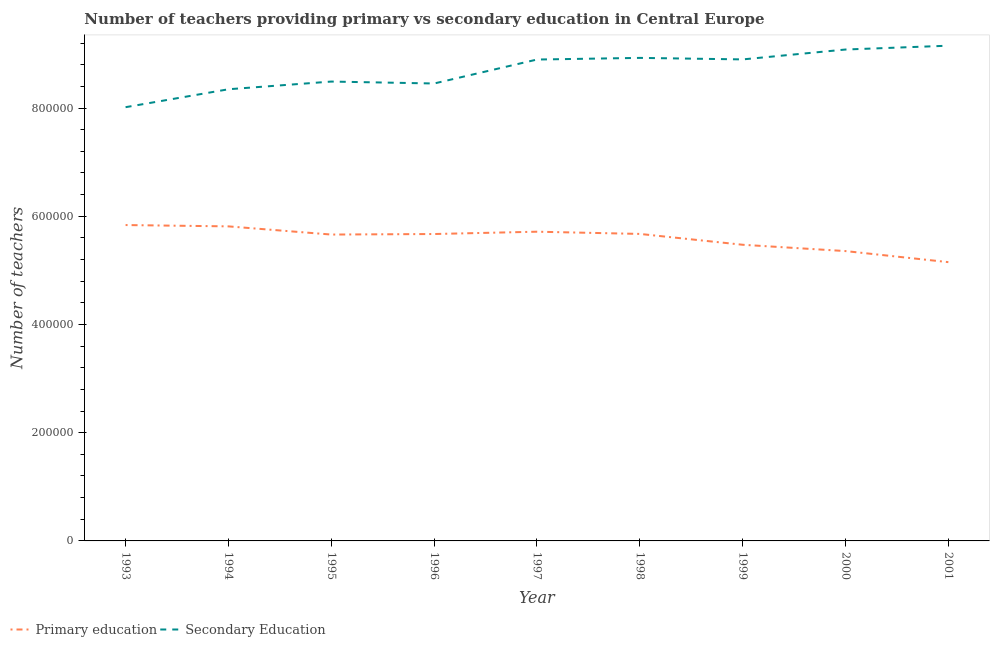How many different coloured lines are there?
Provide a short and direct response. 2. Does the line corresponding to number of secondary teachers intersect with the line corresponding to number of primary teachers?
Offer a very short reply. No. Is the number of lines equal to the number of legend labels?
Make the answer very short. Yes. What is the number of primary teachers in 1994?
Offer a very short reply. 5.81e+05. Across all years, what is the maximum number of secondary teachers?
Provide a succinct answer. 9.15e+05. Across all years, what is the minimum number of secondary teachers?
Your answer should be very brief. 8.02e+05. In which year was the number of primary teachers maximum?
Offer a terse response. 1993. In which year was the number of secondary teachers minimum?
Give a very brief answer. 1993. What is the total number of secondary teachers in the graph?
Ensure brevity in your answer.  7.83e+06. What is the difference between the number of primary teachers in 1995 and that in 1999?
Make the answer very short. 1.89e+04. What is the difference between the number of secondary teachers in 1994 and the number of primary teachers in 1993?
Ensure brevity in your answer.  2.51e+05. What is the average number of secondary teachers per year?
Keep it short and to the point. 8.70e+05. In the year 1999, what is the difference between the number of secondary teachers and number of primary teachers?
Offer a terse response. 3.43e+05. What is the ratio of the number of primary teachers in 1995 to that in 1998?
Your answer should be compact. 1. Is the number of primary teachers in 1997 less than that in 1998?
Your answer should be compact. No. Is the difference between the number of primary teachers in 1993 and 1999 greater than the difference between the number of secondary teachers in 1993 and 1999?
Your response must be concise. Yes. What is the difference between the highest and the second highest number of primary teachers?
Your response must be concise. 2451.12. What is the difference between the highest and the lowest number of primary teachers?
Keep it short and to the point. 6.86e+04. Does the number of primary teachers monotonically increase over the years?
Your answer should be compact. No. How many lines are there?
Your response must be concise. 2. How many years are there in the graph?
Your answer should be compact. 9. Where does the legend appear in the graph?
Your response must be concise. Bottom left. How many legend labels are there?
Keep it short and to the point. 2. What is the title of the graph?
Keep it short and to the point. Number of teachers providing primary vs secondary education in Central Europe. Does "Agricultural land" appear as one of the legend labels in the graph?
Provide a short and direct response. No. What is the label or title of the X-axis?
Ensure brevity in your answer.  Year. What is the label or title of the Y-axis?
Offer a terse response. Number of teachers. What is the Number of teachers of Primary education in 1993?
Make the answer very short. 5.84e+05. What is the Number of teachers in Secondary Education in 1993?
Keep it short and to the point. 8.02e+05. What is the Number of teachers of Primary education in 1994?
Your response must be concise. 5.81e+05. What is the Number of teachers of Secondary Education in 1994?
Provide a succinct answer. 8.35e+05. What is the Number of teachers in Primary education in 1995?
Keep it short and to the point. 5.66e+05. What is the Number of teachers in Secondary Education in 1995?
Your response must be concise. 8.49e+05. What is the Number of teachers in Primary education in 1996?
Your answer should be compact. 5.67e+05. What is the Number of teachers in Secondary Education in 1996?
Provide a short and direct response. 8.45e+05. What is the Number of teachers of Primary education in 1997?
Your answer should be compact. 5.71e+05. What is the Number of teachers of Secondary Education in 1997?
Your response must be concise. 8.90e+05. What is the Number of teachers in Primary education in 1998?
Your answer should be very brief. 5.67e+05. What is the Number of teachers of Secondary Education in 1998?
Provide a succinct answer. 8.93e+05. What is the Number of teachers in Primary education in 1999?
Offer a terse response. 5.47e+05. What is the Number of teachers in Secondary Education in 1999?
Offer a terse response. 8.90e+05. What is the Number of teachers in Primary education in 2000?
Provide a short and direct response. 5.36e+05. What is the Number of teachers of Secondary Education in 2000?
Offer a very short reply. 9.08e+05. What is the Number of teachers of Primary education in 2001?
Your answer should be very brief. 5.15e+05. What is the Number of teachers of Secondary Education in 2001?
Your answer should be compact. 9.15e+05. Across all years, what is the maximum Number of teachers in Primary education?
Your response must be concise. 5.84e+05. Across all years, what is the maximum Number of teachers in Secondary Education?
Ensure brevity in your answer.  9.15e+05. Across all years, what is the minimum Number of teachers in Primary education?
Your answer should be very brief. 5.15e+05. Across all years, what is the minimum Number of teachers of Secondary Education?
Offer a terse response. 8.02e+05. What is the total Number of teachers in Primary education in the graph?
Your answer should be compact. 5.04e+06. What is the total Number of teachers in Secondary Education in the graph?
Make the answer very short. 7.83e+06. What is the difference between the Number of teachers in Primary education in 1993 and that in 1994?
Your answer should be compact. 2451.12. What is the difference between the Number of teachers of Secondary Education in 1993 and that in 1994?
Offer a terse response. -3.31e+04. What is the difference between the Number of teachers in Primary education in 1993 and that in 1995?
Your answer should be very brief. 1.76e+04. What is the difference between the Number of teachers in Secondary Education in 1993 and that in 1995?
Keep it short and to the point. -4.74e+04. What is the difference between the Number of teachers in Primary education in 1993 and that in 1996?
Keep it short and to the point. 1.66e+04. What is the difference between the Number of teachers in Secondary Education in 1993 and that in 1996?
Offer a very short reply. -4.38e+04. What is the difference between the Number of teachers in Primary education in 1993 and that in 1997?
Make the answer very short. 1.23e+04. What is the difference between the Number of teachers in Secondary Education in 1993 and that in 1997?
Offer a very short reply. -8.81e+04. What is the difference between the Number of teachers in Primary education in 1993 and that in 1998?
Make the answer very short. 1.64e+04. What is the difference between the Number of teachers in Secondary Education in 1993 and that in 1998?
Your answer should be very brief. -9.11e+04. What is the difference between the Number of teachers of Primary education in 1993 and that in 1999?
Keep it short and to the point. 3.64e+04. What is the difference between the Number of teachers of Secondary Education in 1993 and that in 1999?
Make the answer very short. -8.83e+04. What is the difference between the Number of teachers in Primary education in 1993 and that in 2000?
Your answer should be very brief. 4.81e+04. What is the difference between the Number of teachers of Secondary Education in 1993 and that in 2000?
Make the answer very short. -1.07e+05. What is the difference between the Number of teachers in Primary education in 1993 and that in 2001?
Provide a succinct answer. 6.86e+04. What is the difference between the Number of teachers in Secondary Education in 1993 and that in 2001?
Give a very brief answer. -1.14e+05. What is the difference between the Number of teachers in Primary education in 1994 and that in 1995?
Provide a succinct answer. 1.51e+04. What is the difference between the Number of teachers in Secondary Education in 1994 and that in 1995?
Keep it short and to the point. -1.42e+04. What is the difference between the Number of teachers of Primary education in 1994 and that in 1996?
Your answer should be very brief. 1.41e+04. What is the difference between the Number of teachers of Secondary Education in 1994 and that in 1996?
Provide a short and direct response. -1.07e+04. What is the difference between the Number of teachers of Primary education in 1994 and that in 1997?
Your answer should be compact. 9834.69. What is the difference between the Number of teachers in Secondary Education in 1994 and that in 1997?
Offer a terse response. -5.49e+04. What is the difference between the Number of teachers of Primary education in 1994 and that in 1998?
Ensure brevity in your answer.  1.39e+04. What is the difference between the Number of teachers in Secondary Education in 1994 and that in 1998?
Your answer should be very brief. -5.80e+04. What is the difference between the Number of teachers of Primary education in 1994 and that in 1999?
Your answer should be very brief. 3.40e+04. What is the difference between the Number of teachers in Secondary Education in 1994 and that in 1999?
Provide a short and direct response. -5.52e+04. What is the difference between the Number of teachers of Primary education in 1994 and that in 2000?
Provide a succinct answer. 4.57e+04. What is the difference between the Number of teachers in Secondary Education in 1994 and that in 2000?
Your answer should be compact. -7.34e+04. What is the difference between the Number of teachers in Primary education in 1994 and that in 2001?
Provide a succinct answer. 6.61e+04. What is the difference between the Number of teachers in Secondary Education in 1994 and that in 2001?
Keep it short and to the point. -8.05e+04. What is the difference between the Number of teachers of Primary education in 1995 and that in 1996?
Your answer should be very brief. -986.69. What is the difference between the Number of teachers in Secondary Education in 1995 and that in 1996?
Your answer should be very brief. 3568.75. What is the difference between the Number of teachers in Primary education in 1995 and that in 1997?
Your response must be concise. -5271.88. What is the difference between the Number of teachers of Secondary Education in 1995 and that in 1997?
Ensure brevity in your answer.  -4.07e+04. What is the difference between the Number of teachers in Primary education in 1995 and that in 1998?
Your answer should be compact. -1163.19. What is the difference between the Number of teachers in Secondary Education in 1995 and that in 1998?
Your answer should be compact. -4.38e+04. What is the difference between the Number of teachers of Primary education in 1995 and that in 1999?
Make the answer very short. 1.89e+04. What is the difference between the Number of teachers of Secondary Education in 1995 and that in 1999?
Your answer should be compact. -4.09e+04. What is the difference between the Number of teachers of Primary education in 1995 and that in 2000?
Give a very brief answer. 3.05e+04. What is the difference between the Number of teachers in Secondary Education in 1995 and that in 2000?
Offer a very short reply. -5.92e+04. What is the difference between the Number of teachers of Primary education in 1995 and that in 2001?
Offer a very short reply. 5.10e+04. What is the difference between the Number of teachers of Secondary Education in 1995 and that in 2001?
Your response must be concise. -6.63e+04. What is the difference between the Number of teachers of Primary education in 1996 and that in 1997?
Your answer should be very brief. -4285.19. What is the difference between the Number of teachers in Secondary Education in 1996 and that in 1997?
Provide a short and direct response. -4.43e+04. What is the difference between the Number of teachers in Primary education in 1996 and that in 1998?
Your answer should be compact. -176.5. What is the difference between the Number of teachers in Secondary Education in 1996 and that in 1998?
Provide a short and direct response. -4.73e+04. What is the difference between the Number of teachers of Primary education in 1996 and that in 1999?
Give a very brief answer. 1.99e+04. What is the difference between the Number of teachers of Secondary Education in 1996 and that in 1999?
Ensure brevity in your answer.  -4.45e+04. What is the difference between the Number of teachers of Primary education in 1996 and that in 2000?
Your answer should be compact. 3.15e+04. What is the difference between the Number of teachers of Secondary Education in 1996 and that in 2000?
Offer a terse response. -6.28e+04. What is the difference between the Number of teachers of Primary education in 1996 and that in 2001?
Your response must be concise. 5.20e+04. What is the difference between the Number of teachers of Secondary Education in 1996 and that in 2001?
Keep it short and to the point. -6.98e+04. What is the difference between the Number of teachers in Primary education in 1997 and that in 1998?
Give a very brief answer. 4108.69. What is the difference between the Number of teachers in Secondary Education in 1997 and that in 1998?
Provide a short and direct response. -3056.06. What is the difference between the Number of teachers of Primary education in 1997 and that in 1999?
Your answer should be very brief. 2.41e+04. What is the difference between the Number of teachers in Secondary Education in 1997 and that in 1999?
Your answer should be very brief. -243.56. What is the difference between the Number of teachers in Primary education in 1997 and that in 2000?
Give a very brief answer. 3.58e+04. What is the difference between the Number of teachers of Secondary Education in 1997 and that in 2000?
Keep it short and to the point. -1.85e+04. What is the difference between the Number of teachers in Primary education in 1997 and that in 2001?
Give a very brief answer. 5.63e+04. What is the difference between the Number of teachers in Secondary Education in 1997 and that in 2001?
Your response must be concise. -2.56e+04. What is the difference between the Number of teachers of Primary education in 1998 and that in 1999?
Your answer should be compact. 2.00e+04. What is the difference between the Number of teachers of Secondary Education in 1998 and that in 1999?
Keep it short and to the point. 2812.5. What is the difference between the Number of teachers in Primary education in 1998 and that in 2000?
Your response must be concise. 3.17e+04. What is the difference between the Number of teachers of Secondary Education in 1998 and that in 2000?
Provide a short and direct response. -1.55e+04. What is the difference between the Number of teachers in Primary education in 1998 and that in 2001?
Keep it short and to the point. 5.22e+04. What is the difference between the Number of teachers in Secondary Education in 1998 and that in 2001?
Give a very brief answer. -2.25e+04. What is the difference between the Number of teachers of Primary education in 1999 and that in 2000?
Offer a terse response. 1.17e+04. What is the difference between the Number of teachers in Secondary Education in 1999 and that in 2000?
Give a very brief answer. -1.83e+04. What is the difference between the Number of teachers in Primary education in 1999 and that in 2001?
Your answer should be compact. 3.21e+04. What is the difference between the Number of teachers of Secondary Education in 1999 and that in 2001?
Provide a succinct answer. -2.53e+04. What is the difference between the Number of teachers in Primary education in 2000 and that in 2001?
Provide a short and direct response. 2.04e+04. What is the difference between the Number of teachers in Secondary Education in 2000 and that in 2001?
Provide a short and direct response. -7063.25. What is the difference between the Number of teachers of Primary education in 1993 and the Number of teachers of Secondary Education in 1994?
Provide a succinct answer. -2.51e+05. What is the difference between the Number of teachers of Primary education in 1993 and the Number of teachers of Secondary Education in 1995?
Offer a very short reply. -2.65e+05. What is the difference between the Number of teachers in Primary education in 1993 and the Number of teachers in Secondary Education in 1996?
Your response must be concise. -2.62e+05. What is the difference between the Number of teachers of Primary education in 1993 and the Number of teachers of Secondary Education in 1997?
Make the answer very short. -3.06e+05. What is the difference between the Number of teachers in Primary education in 1993 and the Number of teachers in Secondary Education in 1998?
Your response must be concise. -3.09e+05. What is the difference between the Number of teachers of Primary education in 1993 and the Number of teachers of Secondary Education in 1999?
Keep it short and to the point. -3.06e+05. What is the difference between the Number of teachers in Primary education in 1993 and the Number of teachers in Secondary Education in 2000?
Offer a terse response. -3.24e+05. What is the difference between the Number of teachers in Primary education in 1993 and the Number of teachers in Secondary Education in 2001?
Keep it short and to the point. -3.31e+05. What is the difference between the Number of teachers in Primary education in 1994 and the Number of teachers in Secondary Education in 1995?
Your response must be concise. -2.68e+05. What is the difference between the Number of teachers in Primary education in 1994 and the Number of teachers in Secondary Education in 1996?
Provide a succinct answer. -2.64e+05. What is the difference between the Number of teachers in Primary education in 1994 and the Number of teachers in Secondary Education in 1997?
Your answer should be very brief. -3.08e+05. What is the difference between the Number of teachers of Primary education in 1994 and the Number of teachers of Secondary Education in 1998?
Your response must be concise. -3.11e+05. What is the difference between the Number of teachers in Primary education in 1994 and the Number of teachers in Secondary Education in 1999?
Make the answer very short. -3.09e+05. What is the difference between the Number of teachers of Primary education in 1994 and the Number of teachers of Secondary Education in 2000?
Offer a terse response. -3.27e+05. What is the difference between the Number of teachers in Primary education in 1994 and the Number of teachers in Secondary Education in 2001?
Ensure brevity in your answer.  -3.34e+05. What is the difference between the Number of teachers of Primary education in 1995 and the Number of teachers of Secondary Education in 1996?
Provide a short and direct response. -2.79e+05. What is the difference between the Number of teachers of Primary education in 1995 and the Number of teachers of Secondary Education in 1997?
Give a very brief answer. -3.23e+05. What is the difference between the Number of teachers of Primary education in 1995 and the Number of teachers of Secondary Education in 1998?
Your answer should be very brief. -3.27e+05. What is the difference between the Number of teachers in Primary education in 1995 and the Number of teachers in Secondary Education in 1999?
Offer a very short reply. -3.24e+05. What is the difference between the Number of teachers of Primary education in 1995 and the Number of teachers of Secondary Education in 2000?
Give a very brief answer. -3.42e+05. What is the difference between the Number of teachers of Primary education in 1995 and the Number of teachers of Secondary Education in 2001?
Provide a short and direct response. -3.49e+05. What is the difference between the Number of teachers of Primary education in 1996 and the Number of teachers of Secondary Education in 1997?
Offer a very short reply. -3.22e+05. What is the difference between the Number of teachers of Primary education in 1996 and the Number of teachers of Secondary Education in 1998?
Offer a very short reply. -3.26e+05. What is the difference between the Number of teachers of Primary education in 1996 and the Number of teachers of Secondary Education in 1999?
Your answer should be very brief. -3.23e+05. What is the difference between the Number of teachers of Primary education in 1996 and the Number of teachers of Secondary Education in 2000?
Give a very brief answer. -3.41e+05. What is the difference between the Number of teachers of Primary education in 1996 and the Number of teachers of Secondary Education in 2001?
Offer a very short reply. -3.48e+05. What is the difference between the Number of teachers in Primary education in 1997 and the Number of teachers in Secondary Education in 1998?
Your answer should be compact. -3.21e+05. What is the difference between the Number of teachers of Primary education in 1997 and the Number of teachers of Secondary Education in 1999?
Your answer should be compact. -3.18e+05. What is the difference between the Number of teachers in Primary education in 1997 and the Number of teachers in Secondary Education in 2000?
Provide a short and direct response. -3.37e+05. What is the difference between the Number of teachers of Primary education in 1997 and the Number of teachers of Secondary Education in 2001?
Offer a very short reply. -3.44e+05. What is the difference between the Number of teachers in Primary education in 1998 and the Number of teachers in Secondary Education in 1999?
Provide a short and direct response. -3.23e+05. What is the difference between the Number of teachers of Primary education in 1998 and the Number of teachers of Secondary Education in 2000?
Keep it short and to the point. -3.41e+05. What is the difference between the Number of teachers of Primary education in 1998 and the Number of teachers of Secondary Education in 2001?
Provide a short and direct response. -3.48e+05. What is the difference between the Number of teachers in Primary education in 1999 and the Number of teachers in Secondary Education in 2000?
Offer a terse response. -3.61e+05. What is the difference between the Number of teachers in Primary education in 1999 and the Number of teachers in Secondary Education in 2001?
Give a very brief answer. -3.68e+05. What is the difference between the Number of teachers in Primary education in 2000 and the Number of teachers in Secondary Education in 2001?
Your response must be concise. -3.80e+05. What is the average Number of teachers in Primary education per year?
Provide a succinct answer. 5.60e+05. What is the average Number of teachers in Secondary Education per year?
Your response must be concise. 8.70e+05. In the year 1993, what is the difference between the Number of teachers in Primary education and Number of teachers in Secondary Education?
Make the answer very short. -2.18e+05. In the year 1994, what is the difference between the Number of teachers in Primary education and Number of teachers in Secondary Education?
Your answer should be compact. -2.53e+05. In the year 1995, what is the difference between the Number of teachers in Primary education and Number of teachers in Secondary Education?
Ensure brevity in your answer.  -2.83e+05. In the year 1996, what is the difference between the Number of teachers in Primary education and Number of teachers in Secondary Education?
Make the answer very short. -2.78e+05. In the year 1997, what is the difference between the Number of teachers in Primary education and Number of teachers in Secondary Education?
Provide a succinct answer. -3.18e+05. In the year 1998, what is the difference between the Number of teachers in Primary education and Number of teachers in Secondary Education?
Offer a very short reply. -3.25e+05. In the year 1999, what is the difference between the Number of teachers of Primary education and Number of teachers of Secondary Education?
Give a very brief answer. -3.43e+05. In the year 2000, what is the difference between the Number of teachers in Primary education and Number of teachers in Secondary Education?
Offer a terse response. -3.73e+05. In the year 2001, what is the difference between the Number of teachers in Primary education and Number of teachers in Secondary Education?
Provide a short and direct response. -4.00e+05. What is the ratio of the Number of teachers in Secondary Education in 1993 to that in 1994?
Your answer should be compact. 0.96. What is the ratio of the Number of teachers of Primary education in 1993 to that in 1995?
Your answer should be compact. 1.03. What is the ratio of the Number of teachers of Secondary Education in 1993 to that in 1995?
Keep it short and to the point. 0.94. What is the ratio of the Number of teachers in Primary education in 1993 to that in 1996?
Your answer should be very brief. 1.03. What is the ratio of the Number of teachers of Secondary Education in 1993 to that in 1996?
Offer a very short reply. 0.95. What is the ratio of the Number of teachers of Primary education in 1993 to that in 1997?
Ensure brevity in your answer.  1.02. What is the ratio of the Number of teachers in Secondary Education in 1993 to that in 1997?
Your answer should be very brief. 0.9. What is the ratio of the Number of teachers of Primary education in 1993 to that in 1998?
Provide a succinct answer. 1.03. What is the ratio of the Number of teachers in Secondary Education in 1993 to that in 1998?
Your answer should be very brief. 0.9. What is the ratio of the Number of teachers in Primary education in 1993 to that in 1999?
Keep it short and to the point. 1.07. What is the ratio of the Number of teachers of Secondary Education in 1993 to that in 1999?
Your answer should be compact. 0.9. What is the ratio of the Number of teachers in Primary education in 1993 to that in 2000?
Offer a terse response. 1.09. What is the ratio of the Number of teachers in Secondary Education in 1993 to that in 2000?
Your answer should be very brief. 0.88. What is the ratio of the Number of teachers of Primary education in 1993 to that in 2001?
Offer a very short reply. 1.13. What is the ratio of the Number of teachers of Secondary Education in 1993 to that in 2001?
Offer a terse response. 0.88. What is the ratio of the Number of teachers of Primary education in 1994 to that in 1995?
Offer a terse response. 1.03. What is the ratio of the Number of teachers in Secondary Education in 1994 to that in 1995?
Give a very brief answer. 0.98. What is the ratio of the Number of teachers of Primary education in 1994 to that in 1996?
Keep it short and to the point. 1.02. What is the ratio of the Number of teachers of Secondary Education in 1994 to that in 1996?
Provide a short and direct response. 0.99. What is the ratio of the Number of teachers in Primary education in 1994 to that in 1997?
Provide a succinct answer. 1.02. What is the ratio of the Number of teachers in Secondary Education in 1994 to that in 1997?
Provide a short and direct response. 0.94. What is the ratio of the Number of teachers in Primary education in 1994 to that in 1998?
Your answer should be very brief. 1.02. What is the ratio of the Number of teachers of Secondary Education in 1994 to that in 1998?
Your response must be concise. 0.94. What is the ratio of the Number of teachers of Primary education in 1994 to that in 1999?
Offer a very short reply. 1.06. What is the ratio of the Number of teachers of Secondary Education in 1994 to that in 1999?
Keep it short and to the point. 0.94. What is the ratio of the Number of teachers in Primary education in 1994 to that in 2000?
Provide a short and direct response. 1.09. What is the ratio of the Number of teachers of Secondary Education in 1994 to that in 2000?
Your answer should be compact. 0.92. What is the ratio of the Number of teachers in Primary education in 1994 to that in 2001?
Ensure brevity in your answer.  1.13. What is the ratio of the Number of teachers in Secondary Education in 1994 to that in 2001?
Offer a terse response. 0.91. What is the ratio of the Number of teachers in Primary education in 1995 to that in 1997?
Your answer should be compact. 0.99. What is the ratio of the Number of teachers of Secondary Education in 1995 to that in 1997?
Offer a very short reply. 0.95. What is the ratio of the Number of teachers of Secondary Education in 1995 to that in 1998?
Offer a terse response. 0.95. What is the ratio of the Number of teachers in Primary education in 1995 to that in 1999?
Your response must be concise. 1.03. What is the ratio of the Number of teachers in Secondary Education in 1995 to that in 1999?
Your answer should be compact. 0.95. What is the ratio of the Number of teachers of Primary education in 1995 to that in 2000?
Keep it short and to the point. 1.06. What is the ratio of the Number of teachers of Secondary Education in 1995 to that in 2000?
Your response must be concise. 0.93. What is the ratio of the Number of teachers of Primary education in 1995 to that in 2001?
Keep it short and to the point. 1.1. What is the ratio of the Number of teachers in Secondary Education in 1995 to that in 2001?
Offer a terse response. 0.93. What is the ratio of the Number of teachers in Primary education in 1996 to that in 1997?
Offer a terse response. 0.99. What is the ratio of the Number of teachers of Secondary Education in 1996 to that in 1997?
Ensure brevity in your answer.  0.95. What is the ratio of the Number of teachers of Primary education in 1996 to that in 1998?
Provide a succinct answer. 1. What is the ratio of the Number of teachers of Secondary Education in 1996 to that in 1998?
Your answer should be very brief. 0.95. What is the ratio of the Number of teachers of Primary education in 1996 to that in 1999?
Your response must be concise. 1.04. What is the ratio of the Number of teachers of Secondary Education in 1996 to that in 1999?
Provide a succinct answer. 0.95. What is the ratio of the Number of teachers in Primary education in 1996 to that in 2000?
Offer a terse response. 1.06. What is the ratio of the Number of teachers in Secondary Education in 1996 to that in 2000?
Your answer should be compact. 0.93. What is the ratio of the Number of teachers of Primary education in 1996 to that in 2001?
Your answer should be very brief. 1.1. What is the ratio of the Number of teachers of Secondary Education in 1996 to that in 2001?
Make the answer very short. 0.92. What is the ratio of the Number of teachers of Primary education in 1997 to that in 1999?
Your answer should be compact. 1.04. What is the ratio of the Number of teachers in Primary education in 1997 to that in 2000?
Your answer should be very brief. 1.07. What is the ratio of the Number of teachers of Secondary Education in 1997 to that in 2000?
Provide a succinct answer. 0.98. What is the ratio of the Number of teachers of Primary education in 1997 to that in 2001?
Your answer should be very brief. 1.11. What is the ratio of the Number of teachers in Secondary Education in 1997 to that in 2001?
Your answer should be compact. 0.97. What is the ratio of the Number of teachers of Primary education in 1998 to that in 1999?
Your response must be concise. 1.04. What is the ratio of the Number of teachers in Primary education in 1998 to that in 2000?
Provide a succinct answer. 1.06. What is the ratio of the Number of teachers in Primary education in 1998 to that in 2001?
Ensure brevity in your answer.  1.1. What is the ratio of the Number of teachers of Secondary Education in 1998 to that in 2001?
Make the answer very short. 0.98. What is the ratio of the Number of teachers in Primary education in 1999 to that in 2000?
Ensure brevity in your answer.  1.02. What is the ratio of the Number of teachers in Secondary Education in 1999 to that in 2000?
Provide a succinct answer. 0.98. What is the ratio of the Number of teachers of Primary education in 1999 to that in 2001?
Make the answer very short. 1.06. What is the ratio of the Number of teachers in Secondary Education in 1999 to that in 2001?
Keep it short and to the point. 0.97. What is the ratio of the Number of teachers in Primary education in 2000 to that in 2001?
Provide a short and direct response. 1.04. What is the difference between the highest and the second highest Number of teachers of Primary education?
Provide a succinct answer. 2451.12. What is the difference between the highest and the second highest Number of teachers of Secondary Education?
Give a very brief answer. 7063.25. What is the difference between the highest and the lowest Number of teachers of Primary education?
Provide a short and direct response. 6.86e+04. What is the difference between the highest and the lowest Number of teachers of Secondary Education?
Ensure brevity in your answer.  1.14e+05. 